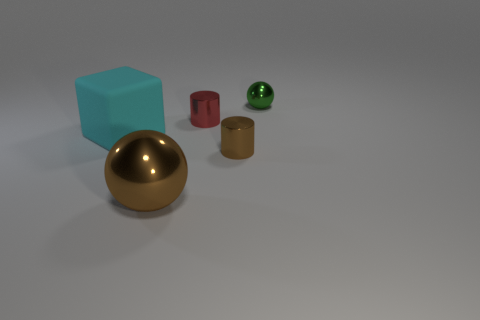How many other things have the same size as the cyan matte object?
Make the answer very short. 1. Are any cubes visible?
Offer a very short reply. Yes. Are there any other things that have the same color as the large block?
Provide a short and direct response. No. What shape is the small green thing that is the same material as the large sphere?
Ensure brevity in your answer.  Sphere. There is a small metallic cylinder that is behind the brown metal thing right of the ball on the left side of the green object; what is its color?
Provide a succinct answer. Red. Is the number of cubes that are right of the large brown metallic thing the same as the number of small green rubber cylinders?
Offer a terse response. Yes. Are there any other things that are made of the same material as the cyan block?
Give a very brief answer. No. There is a large metallic thing; is its color the same as the small cylinder in front of the red metallic cylinder?
Your answer should be very brief. Yes. Is there a tiny green shiny thing in front of the tiny metallic cylinder that is right of the tiny cylinder that is behind the rubber thing?
Keep it short and to the point. No. Is the number of shiny balls right of the brown ball less than the number of tiny brown metal cylinders?
Offer a terse response. No. 